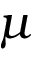<formula> <loc_0><loc_0><loc_500><loc_500>\mu</formula> 